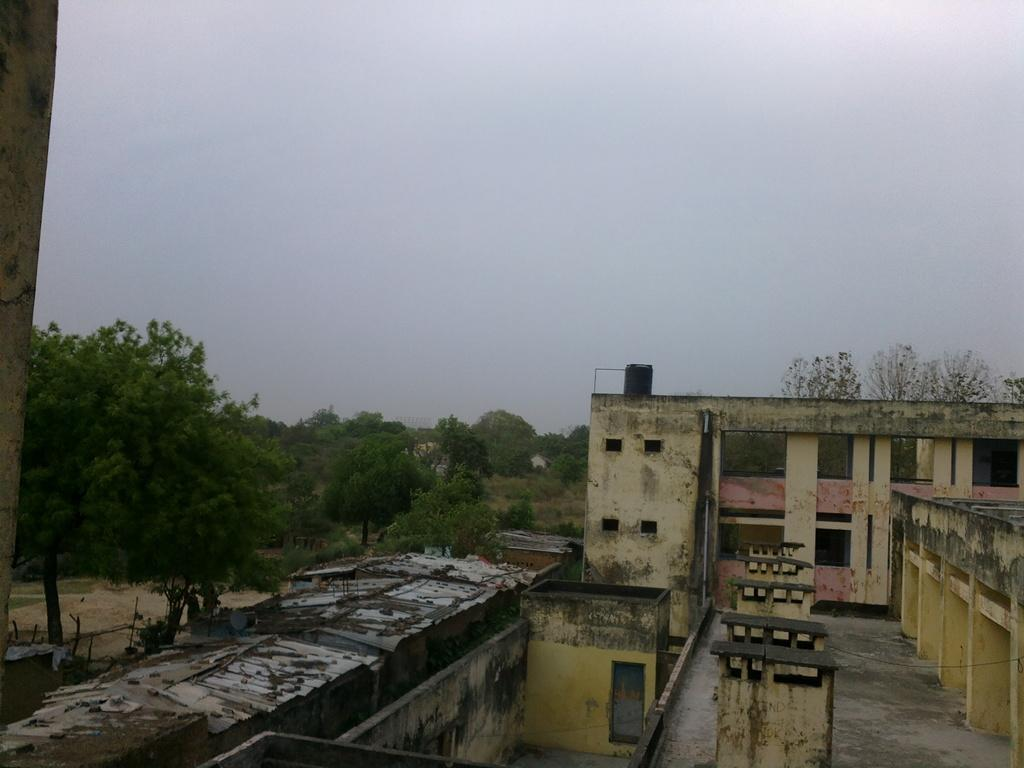What type of structures are present in the image? There are buildings in the image. What can be seen on the left side of the image? There are trees on the left side of the image. What is visible at the top of the image? The sky is visible at the top of the image. Can you see any matches being used to light a fire in the yard in the image? There is no yard or matches present in the image; it features buildings and trees. What type of burst can be seen in the image? There is no burst present in the image. 